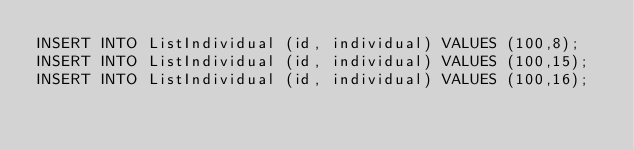<code> <loc_0><loc_0><loc_500><loc_500><_SQL_>INSERT INTO ListIndividual (id, individual) VALUES (100,8);
INSERT INTO ListIndividual (id, individual) VALUES (100,15);
INSERT INTO ListIndividual (id, individual) VALUES (100,16);
</code> 